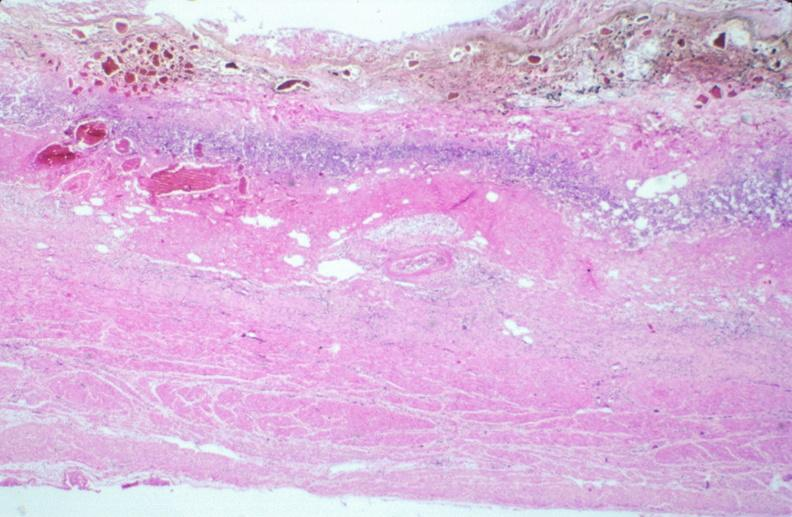s gastrointestinal present?
Answer the question using a single word or phrase. Yes 